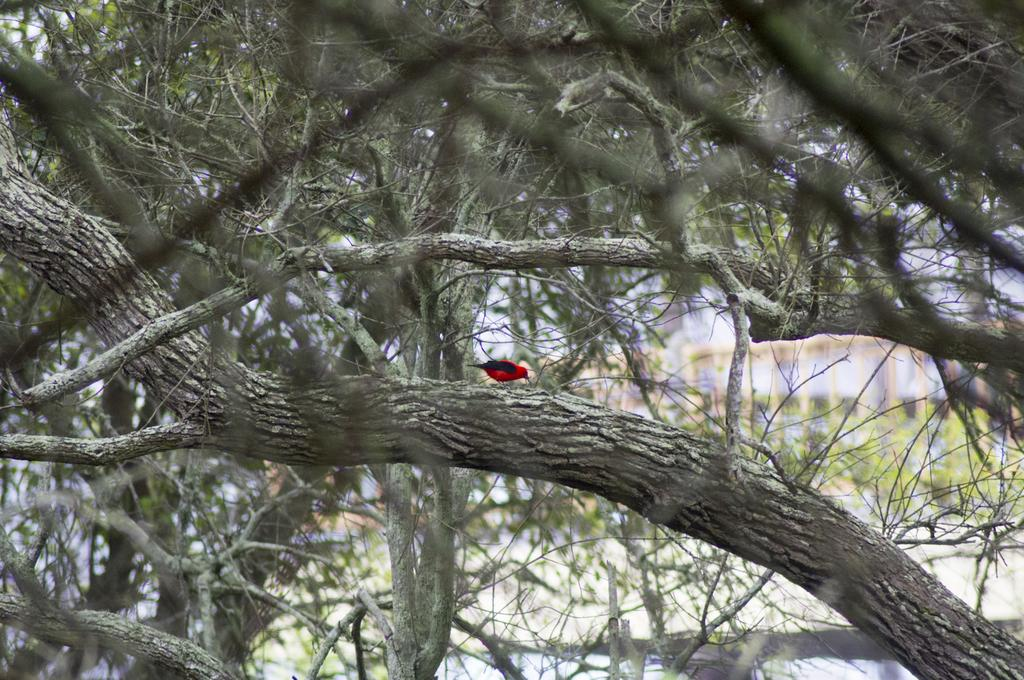What is the main subject in the middle of the image? There is a bird in the middle of the image. What can be seen in the background of the image? There are trees in the background of the image. How many dinosaurs are visible in the image? There are no dinosaurs present in the image. What type of station is depicted in the image? There is no station depicted in the image. 